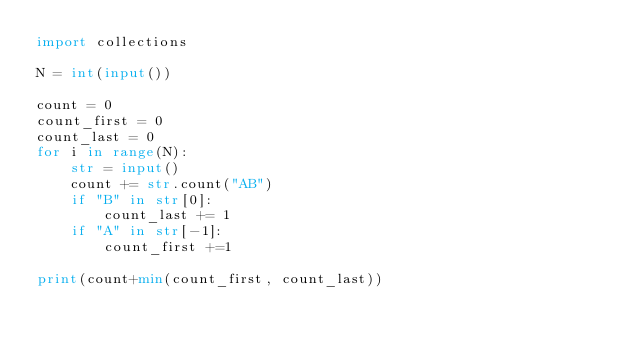Convert code to text. <code><loc_0><loc_0><loc_500><loc_500><_Python_>import collections

N = int(input())

count = 0
count_first = 0
count_last = 0
for i in range(N):
    str = input()
    count += str.count("AB")
    if "B" in str[0]:
        count_last += 1
    if "A" in str[-1]:
        count_first +=1

print(count+min(count_first, count_last))</code> 